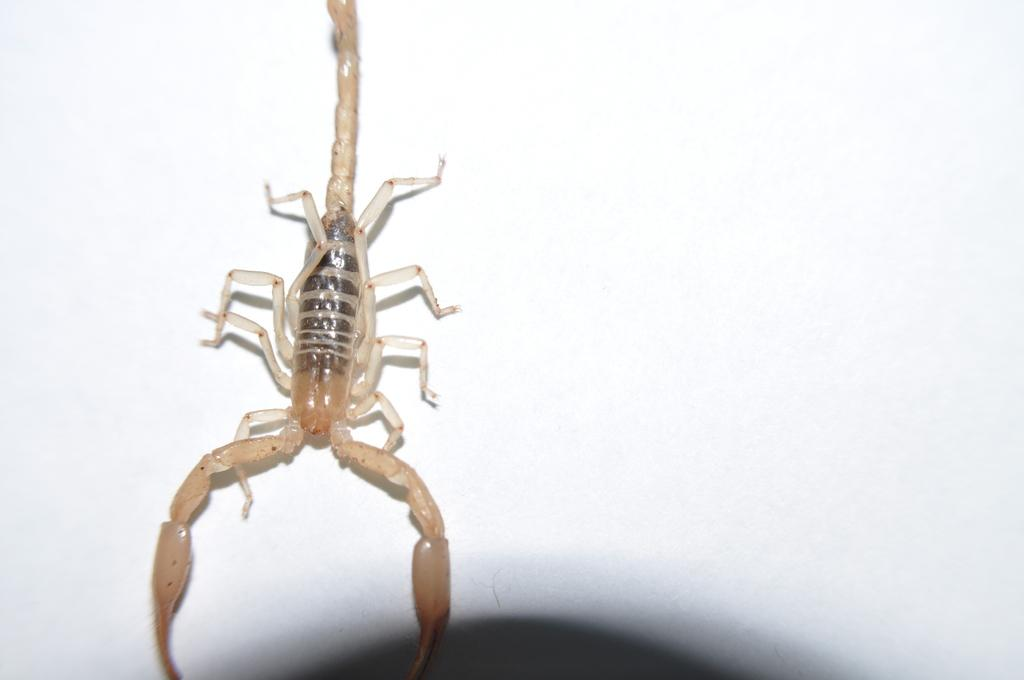What is the main subject of the image? The main subject of the image is a scorpion. Where is the scorpion located in the image? The scorpion is in the center of the image. What colors can be seen on the scorpion? The scorpion has black and cream color. Are there any fairies flying around the scorpion in the image? No, there are no fairies present in the image. What is the angle of the slope in the image? There is no slope present in the image; it features a scorpion in the center. 